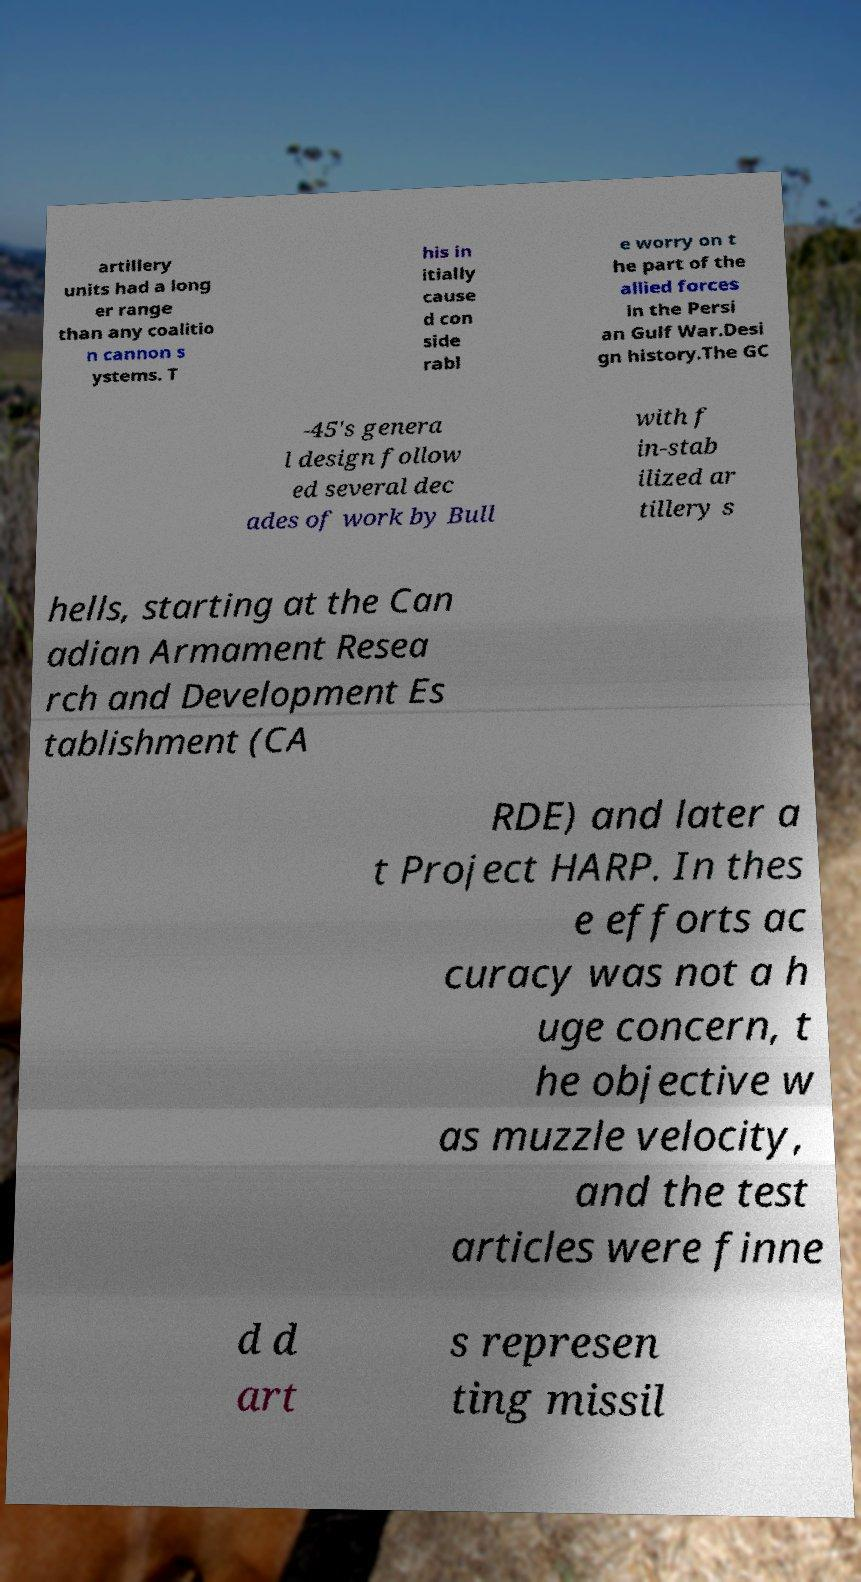Please read and relay the text visible in this image. What does it say? artillery units had a long er range than any coalitio n cannon s ystems. T his in itially cause d con side rabl e worry on t he part of the allied forces in the Persi an Gulf War.Desi gn history.The GC -45's genera l design follow ed several dec ades of work by Bull with f in-stab ilized ar tillery s hells, starting at the Can adian Armament Resea rch and Development Es tablishment (CA RDE) and later a t Project HARP. In thes e efforts ac curacy was not a h uge concern, t he objective w as muzzle velocity, and the test articles were finne d d art s represen ting missil 